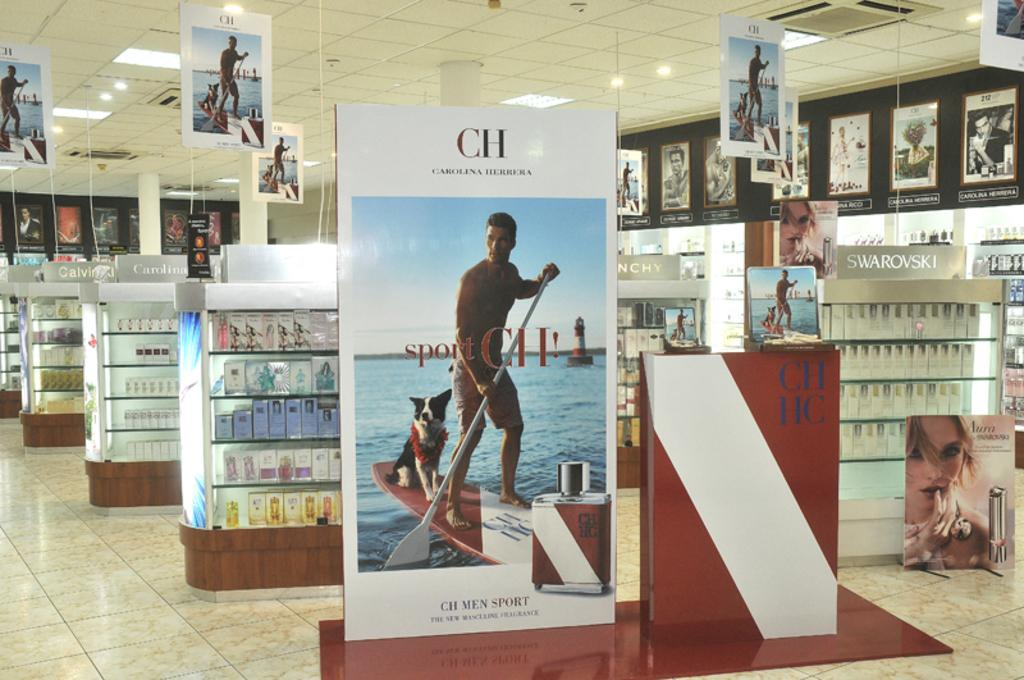<image>
Provide a brief description of the given image. a cosmetic store with a CH commercial board at the front 